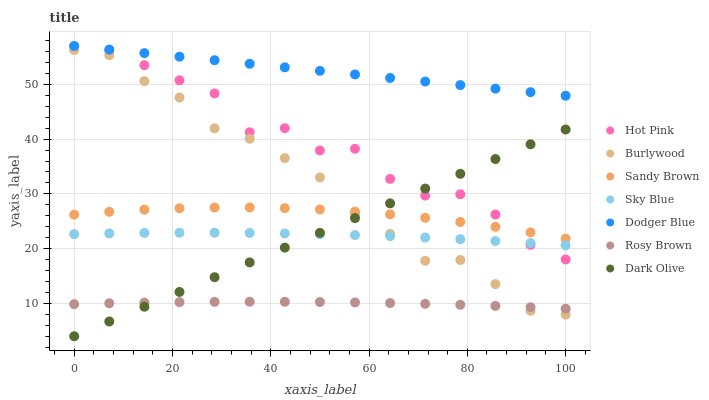Does Rosy Brown have the minimum area under the curve?
Answer yes or no. Yes. Does Dodger Blue have the maximum area under the curve?
Answer yes or no. Yes. Does Burlywood have the minimum area under the curve?
Answer yes or no. No. Does Burlywood have the maximum area under the curve?
Answer yes or no. No. Is Dark Olive the smoothest?
Answer yes or no. Yes. Is Hot Pink the roughest?
Answer yes or no. Yes. Is Burlywood the smoothest?
Answer yes or no. No. Is Burlywood the roughest?
Answer yes or no. No. Does Dark Olive have the lowest value?
Answer yes or no. Yes. Does Burlywood have the lowest value?
Answer yes or no. No. Does Dodger Blue have the highest value?
Answer yes or no. Yes. Does Burlywood have the highest value?
Answer yes or no. No. Is Rosy Brown less than Hot Pink?
Answer yes or no. Yes. Is Sandy Brown greater than Sky Blue?
Answer yes or no. Yes. Does Dark Olive intersect Burlywood?
Answer yes or no. Yes. Is Dark Olive less than Burlywood?
Answer yes or no. No. Is Dark Olive greater than Burlywood?
Answer yes or no. No. Does Rosy Brown intersect Hot Pink?
Answer yes or no. No. 